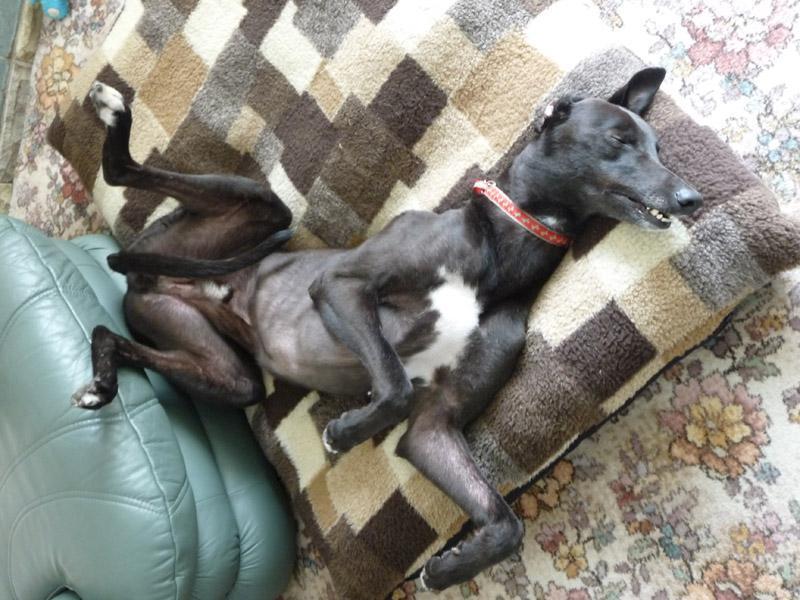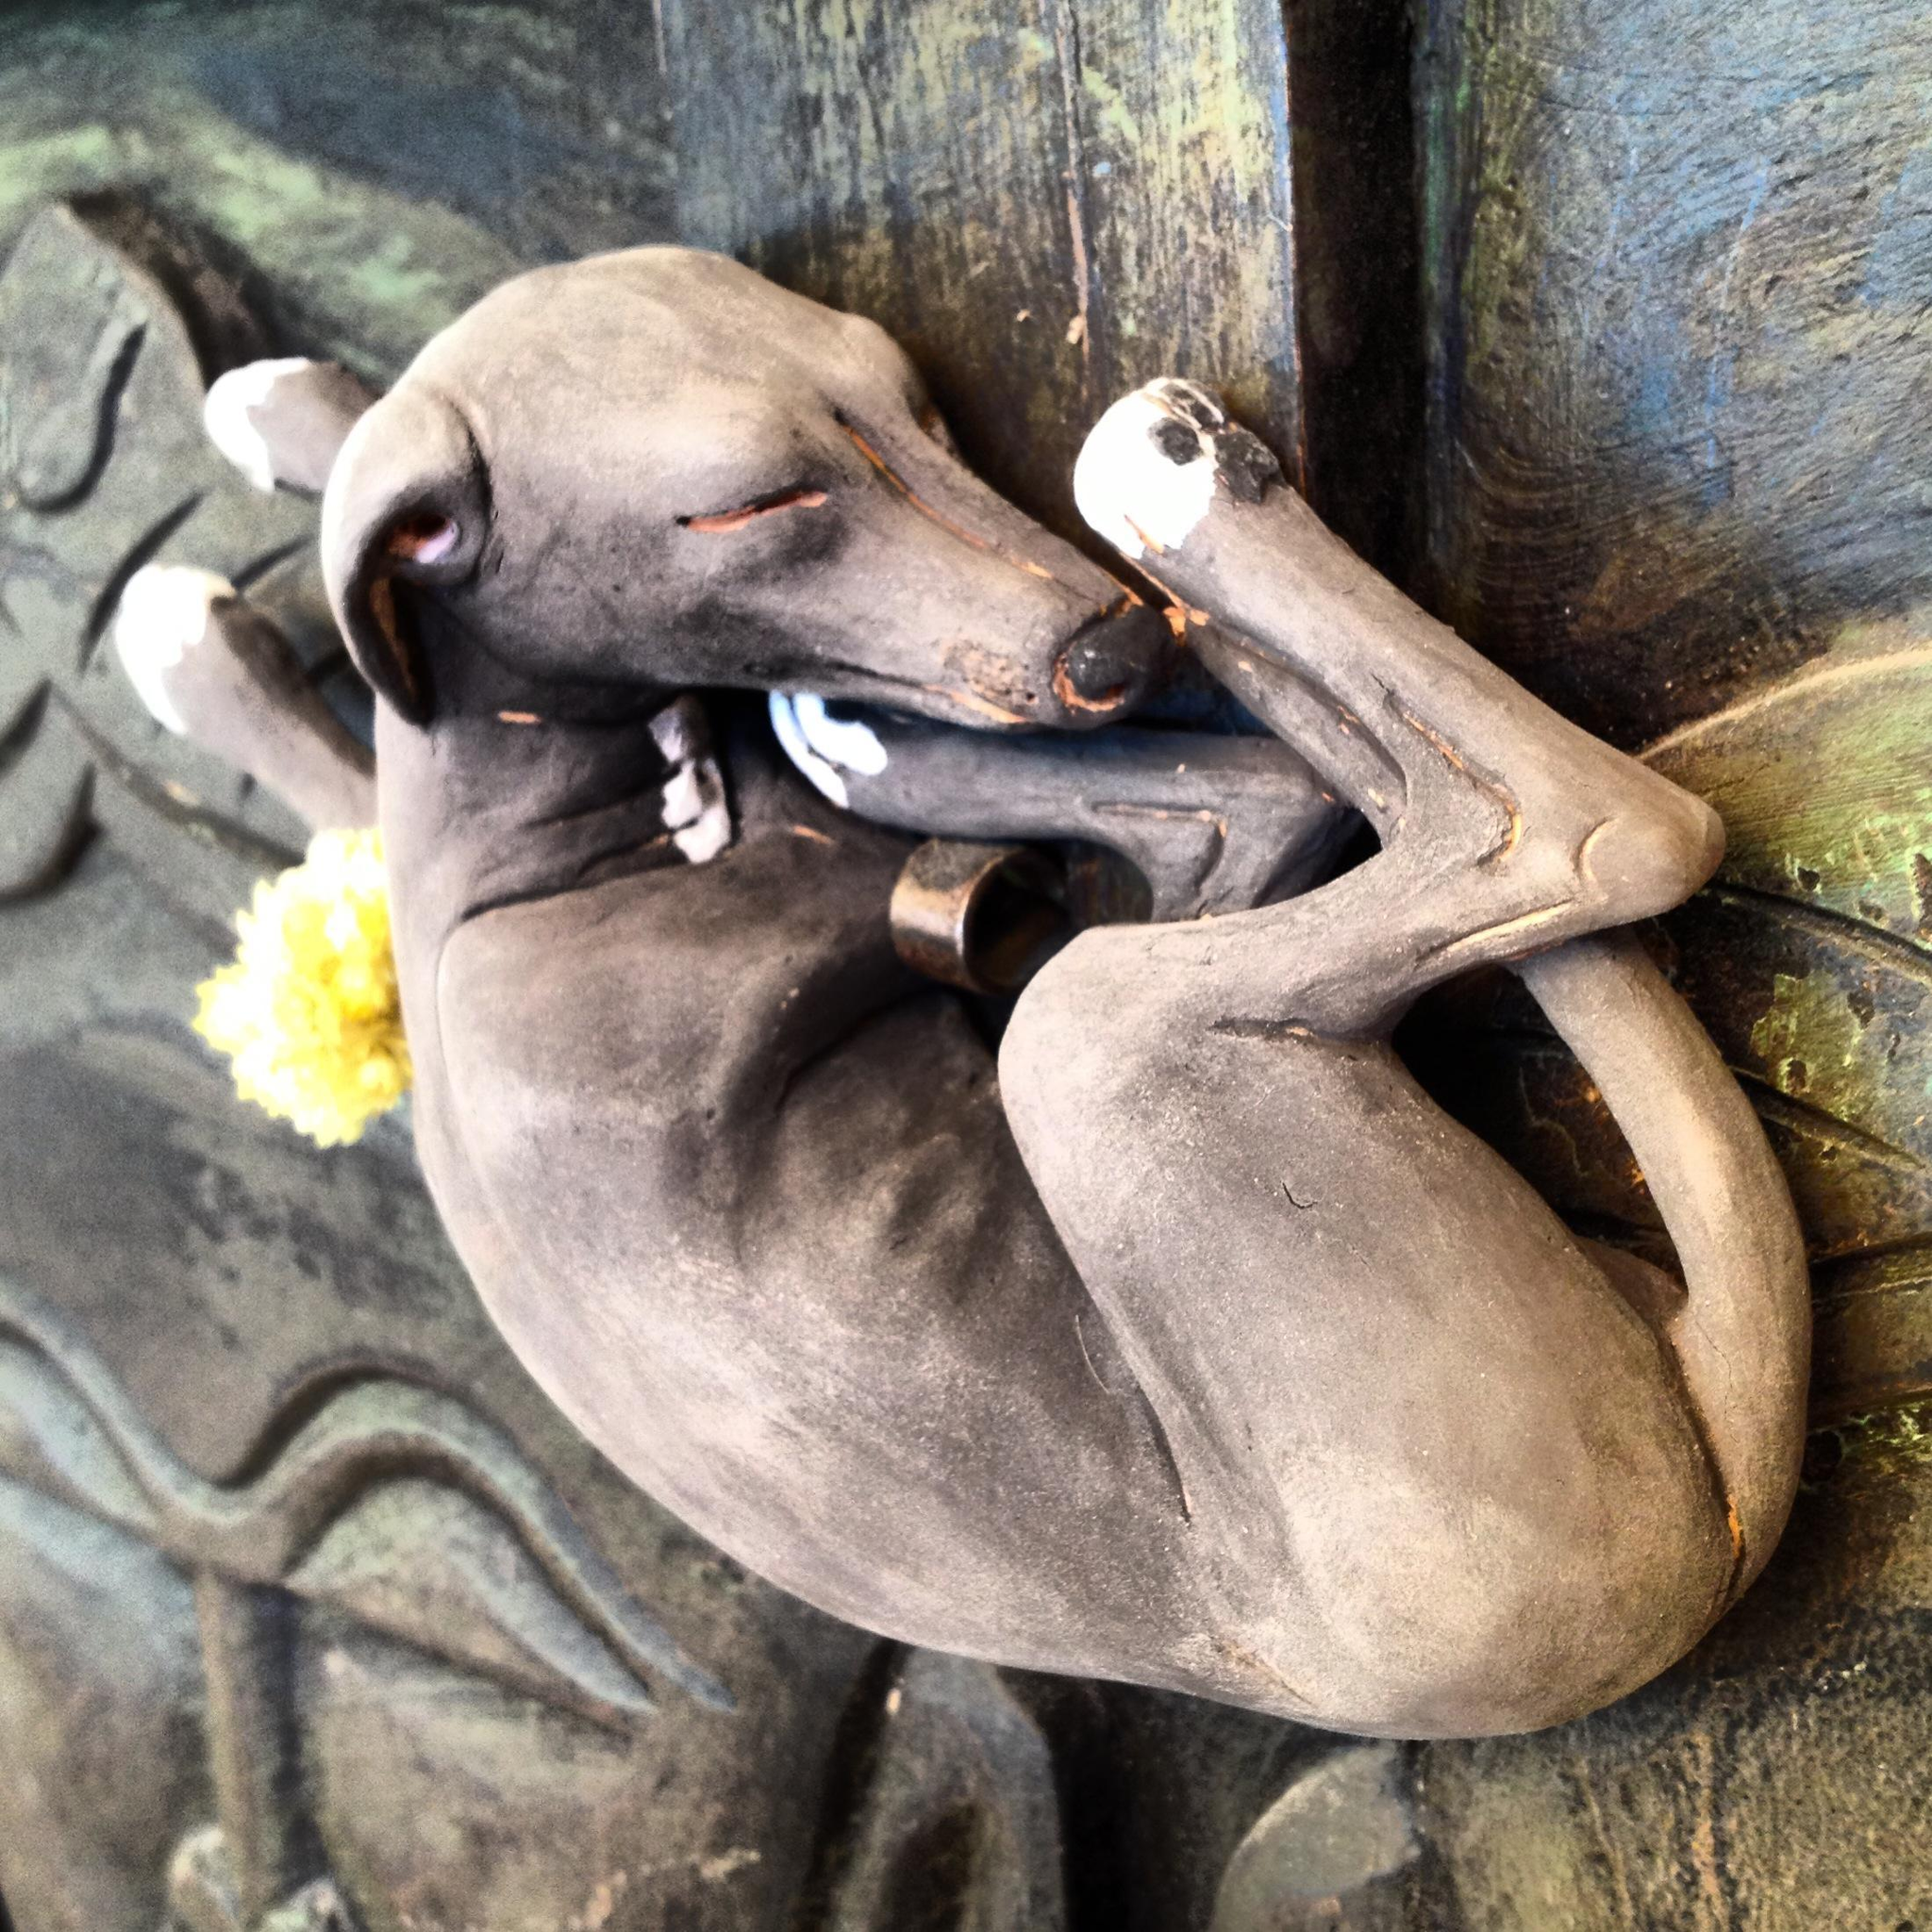The first image is the image on the left, the second image is the image on the right. Evaluate the accuracy of this statement regarding the images: "One of the images shows a brown dog with a ball in its mouth.". Is it true? Answer yes or no. No. The first image is the image on the left, the second image is the image on the right. Evaluate the accuracy of this statement regarding the images: "All dogs are sleeping.". Is it true? Answer yes or no. Yes. 